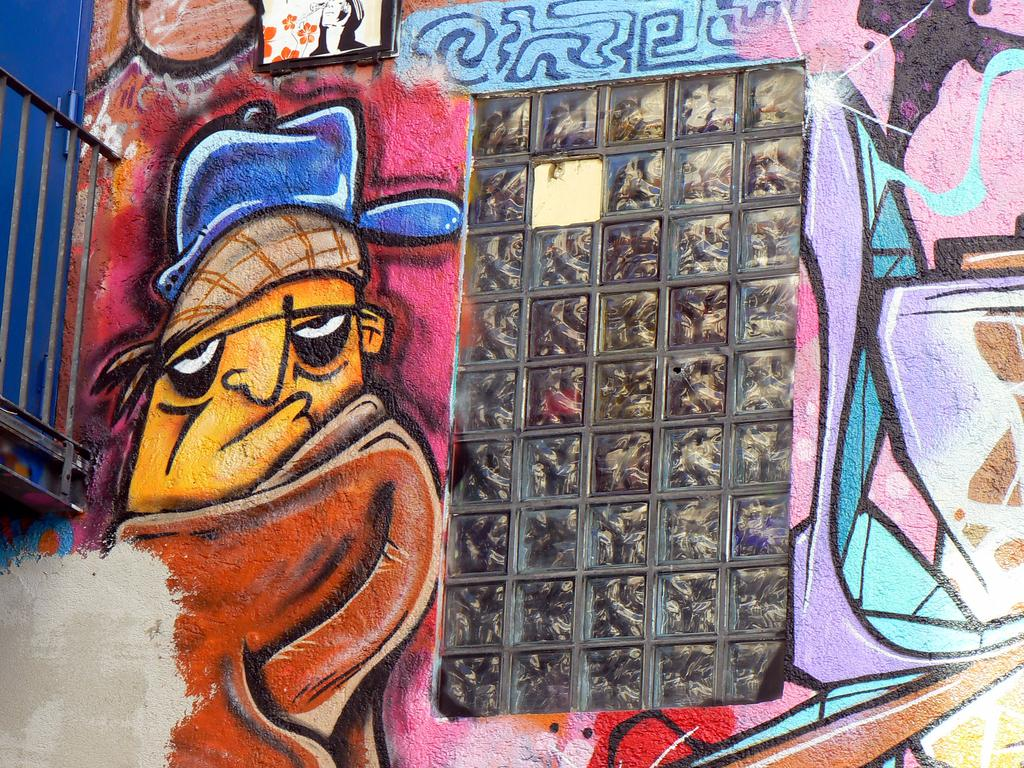What is depicted on the wall in the image? There is a painting of a person on the wall. What can be seen on the left side of the image? There is a railing on the left side of the image. Is there any entrance or exit visible in the image? Yes, there is a door in the image. How many boats are visible in the image? There are no boats present in the image. Are there any bells hanging from the railing in the image? There are no bells visible in the image. 